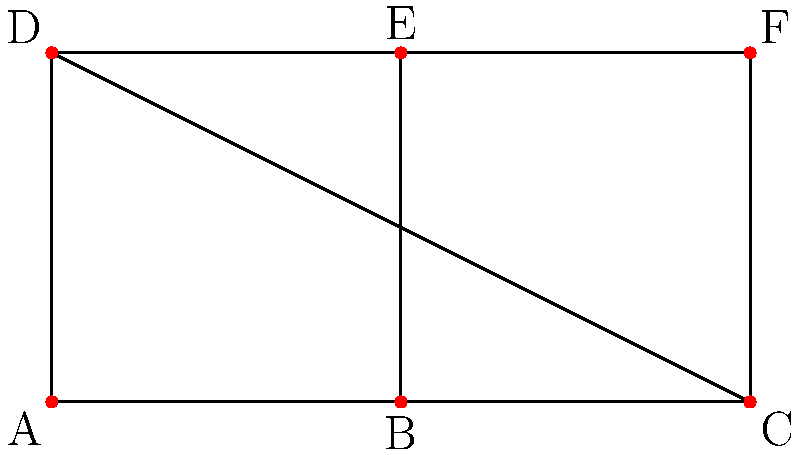In a parallel computing setup for fluid dynamics simulations, a 2D mesh network topology is used as shown in the figure. What is the maximum number of hops required for a message to travel between any two nodes in this network, assuming messages can only travel along the edges? To find the maximum number of hops in this mesh network, we need to:

1. Identify the two nodes that are farthest apart in terms of network distance.
2. Count the minimum number of edges (hops) required to connect these nodes.

Step 1: Identifying the farthest nodes
The farthest nodes in this 2x3 mesh network are the diagonal corners. There are four pairs of diagonal corners:
- A and F
- C and D
- A and C
- D and F

Step 2: Counting the hops
Let's count the hops for each pair:

- A to F: A → B → C → F (3 hops) or A → D → E → F (3 hops)
- C to D: C → B → A → D (3 hops) or C → F → E → D (3 hops)
- A to C: A → B → C (2 hops)
- D to F: D → E → F (2 hops)

The maximum number of hops among these paths is 3.

Therefore, the maximum number of hops required for a message to travel between any two nodes in this network is 3.
Answer: 3 hops 